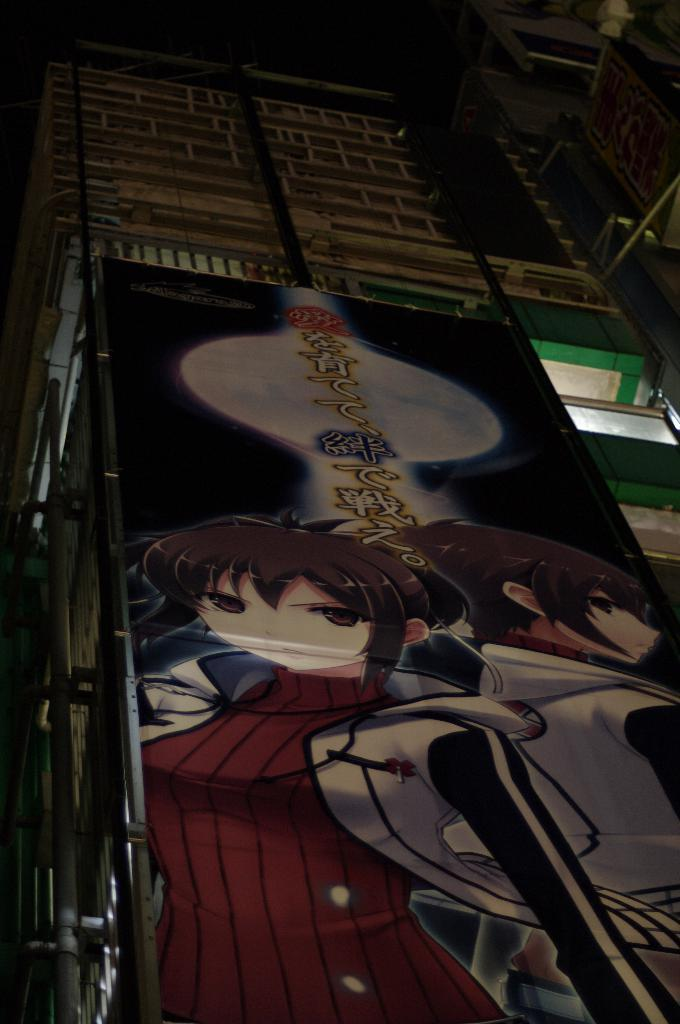What type of image is being described? The image is a poster. How is the poster displayed? The poster is attached to a building. What architectural feature can be seen in the image? There is a window with a glass door in the image. What other objects are visible on the building wall? There are pipes attached to the building wall in the image. What type of farm animals can be seen in the image? There are no farm animals present in the image; it is a poster attached to a building with a window and pipes. How does the fowl interact with the pipes in the image? There is no fowl present in the image, so it cannot interact with the pipes. 